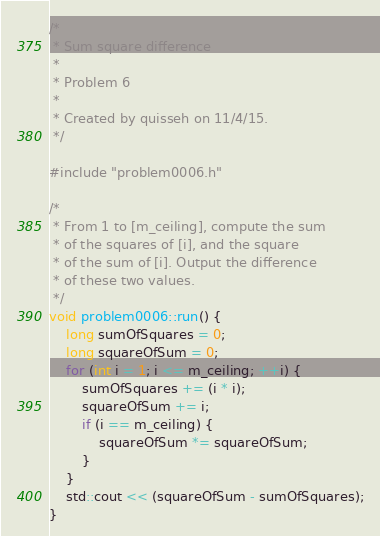Convert code to text. <code><loc_0><loc_0><loc_500><loc_500><_C++_>/*
 * Sum square difference
 *
 * Problem 6
 *
 * Created by quisseh on 11/4/15.
 */

#include "problem0006.h"

/*
 * From 1 to [m_ceiling], compute the sum
 * of the squares of [i], and the square
 * of the sum of [i]. Output the difference
 * of these two values.
 */
void problem0006::run() {
    long sumOfSquares = 0;
    long squareOfSum = 0;
    for (int i = 1; i <= m_ceiling; ++i) {
        sumOfSquares += (i * i);
        squareOfSum += i;
        if (i == m_ceiling) {
            squareOfSum *= squareOfSum;
        }
    }
    std::cout << (squareOfSum - sumOfSquares);
}
</code> 